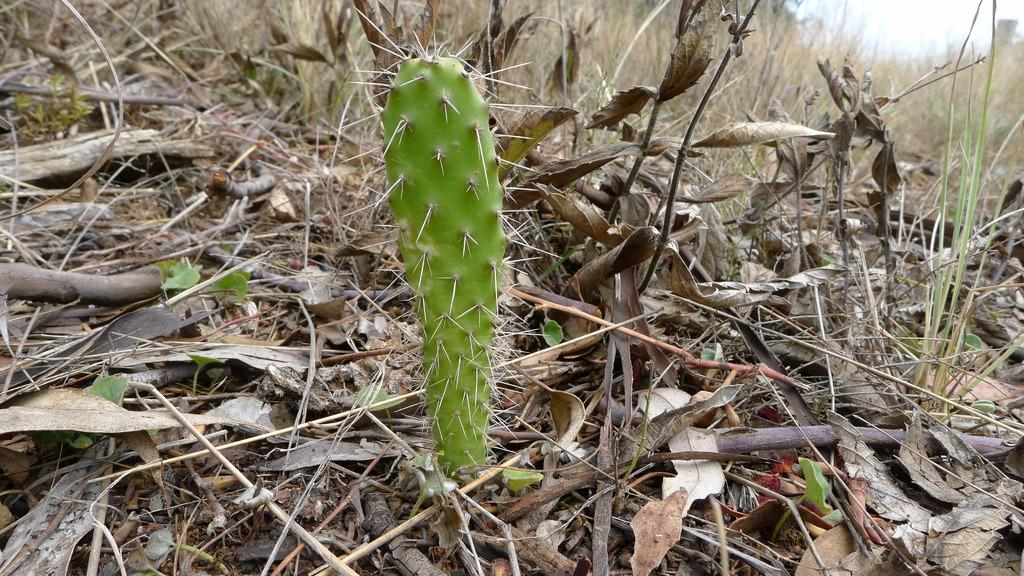What type of plant can be seen in the image? There is a cactus in the image. What is the condition of the leaves in the image? There are dry leaves in the image. What type of vegetation is present in the image? There is grass in the image. What else can be seen in the image besides the cactus and grass? There are plants and sticks in the image. What type of bear can be seen playing with the owner in the image? There is no bear or owner present in the image; it only features plants and vegetation. 